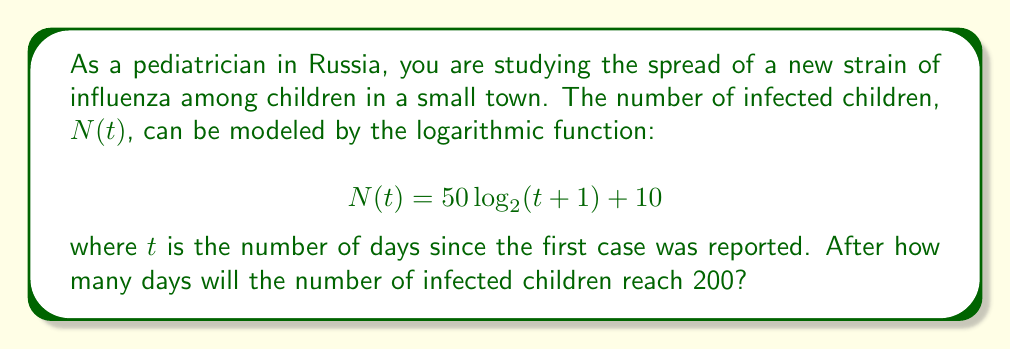Help me with this question. To solve this problem, we need to follow these steps:

1) We are given the logarithmic function:
   $$N(t) = 50 \log_2(t+1) + 10$$

2) We want to find $t$ when $N(t) = 200$. So, let's set up the equation:
   $$200 = 50 \log_2(t+1) + 10$$

3) Subtract 10 from both sides:
   $$190 = 50 \log_2(t+1)$$

4) Divide both sides by 50:
   $$3.8 = \log_2(t+1)$$

5) To solve for $t$, we need to apply the inverse function of $\log_2$, which is $2^x$:
   $$2^{3.8} = t+1$$

6) Calculate $2^{3.8}$:
   $$13.93 \approx t+1$$

7) Subtract 1 from both sides:
   $$12.93 \approx t$$

8) Since we're dealing with days, we need to round up to the nearest whole number:
   $$t = 13$$

Therefore, it will take 13 days for the number of infected children to reach 200.
Answer: 13 days 